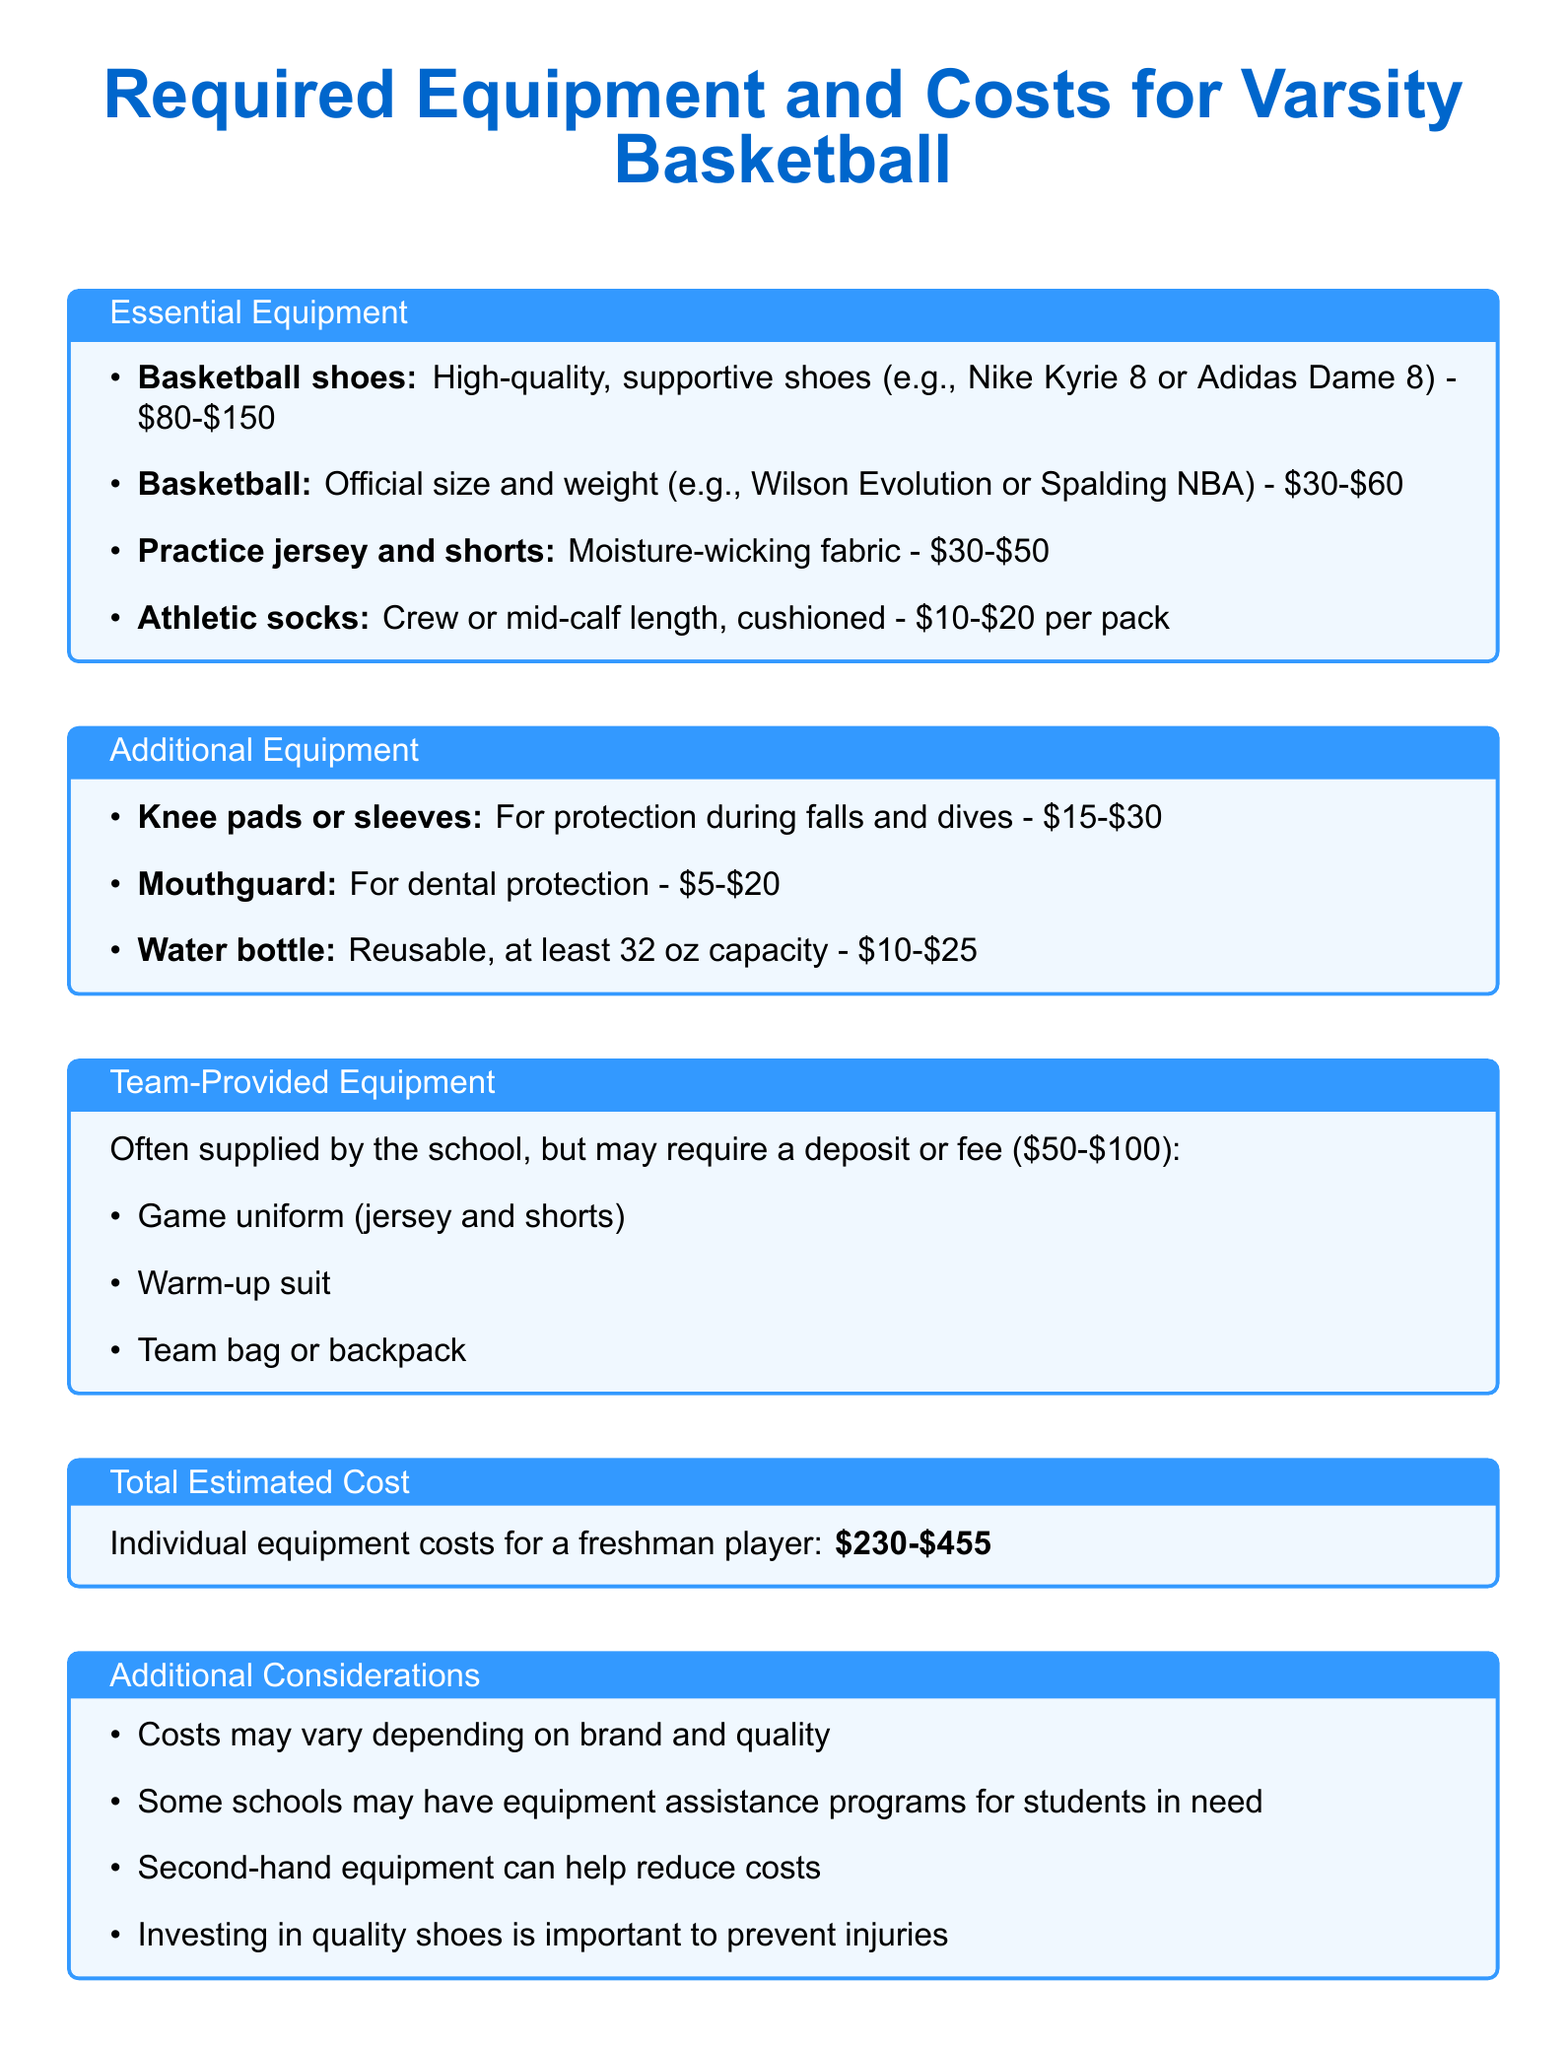What are the essential pieces of equipment for varsity basketball? The essential equipment includes basketball shoes, basketball, practice jersey and shorts, and athletic socks.
Answer: Basketball shoes, basketball, practice jersey and shorts, athletic socks What is the estimated cost range for basketball shoes? The estimated cost range for basketball shoes is provided in the document, stating it will be between $80 and $150.
Answer: $80-$150 How much does a mouthguard cost? The document specifies the estimated cost range for a mouthguard, which is from $5 to $20.
Answer: $5-$20 What is the total estimated cost for individual equipment? The total estimated cost for individual equipment is stated in the document, summarizing the cost for a freshman player.
Answer: $230-$455 What is included in the team-provided equipment? The document lists three items included in the team-provided equipment: game uniform, warm-up suit, team bag or backpack.
Answer: Game uniform, warm-up suit, team bag or backpack How can one reduce costs on sports equipment? The document suggests several strategies, including looking for second-hand equipment and considering school equipment assistance programs.
Answer: Second-hand equipment, equipment assistance programs What type of fabric should practice jerseys and shorts be made of? The document indicates that practice jerseys and shorts should be made of moisture-wicking fabric.
Answer: Moisture-wicking fabric What is an important consideration for buying basketball shoes? The document highlights the importance of investing in quality shoes to prevent injuries as a key consideration.
Answer: Prevent injuries 